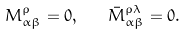Convert formula to latex. <formula><loc_0><loc_0><loc_500><loc_500>M _ { \alpha \beta } ^ { \rho } = 0 , \quad \bar { M } _ { \alpha \beta } ^ { \rho \lambda } = 0 .</formula> 